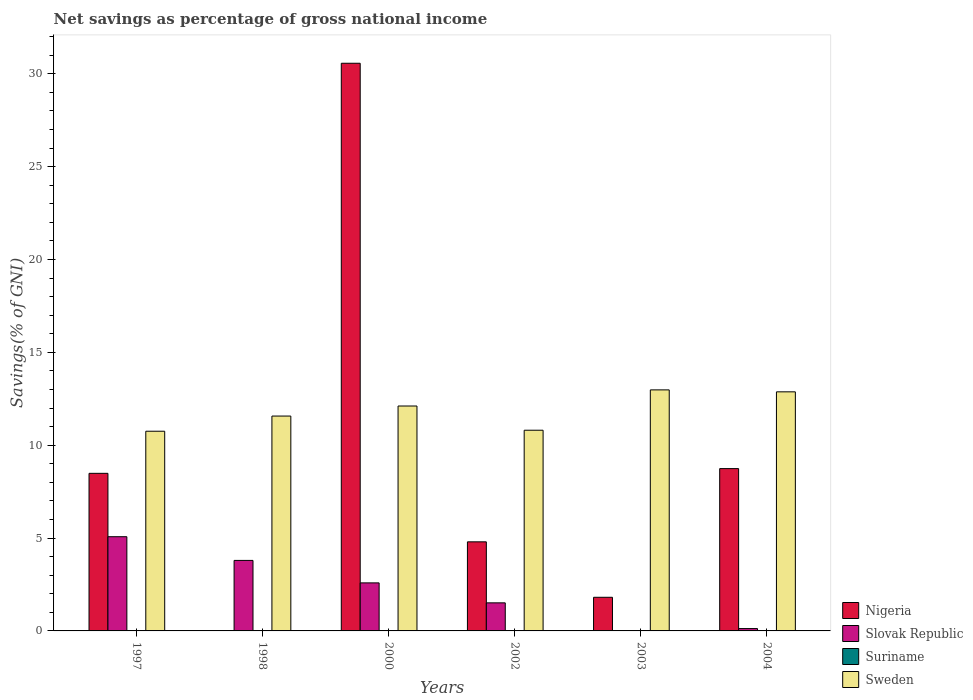How many bars are there on the 1st tick from the right?
Your response must be concise. 3. What is the label of the 4th group of bars from the left?
Give a very brief answer. 2002. What is the total savings in Suriname in 1997?
Your answer should be very brief. 0. Across all years, what is the maximum total savings in Slovak Republic?
Offer a terse response. 5.07. What is the total total savings in Slovak Republic in the graph?
Your answer should be compact. 13.09. What is the difference between the total savings in Sweden in 1998 and that in 2004?
Offer a very short reply. -1.3. What is the difference between the total savings in Nigeria in 2000 and the total savings in Slovak Republic in 1997?
Your response must be concise. 25.49. What is the average total savings in Nigeria per year?
Ensure brevity in your answer.  9.07. In the year 2000, what is the difference between the total savings in Sweden and total savings in Slovak Republic?
Offer a terse response. 9.52. In how many years, is the total savings in Suriname greater than 26 %?
Give a very brief answer. 0. What is the ratio of the total savings in Nigeria in 2000 to that in 2003?
Your answer should be compact. 16.88. Is the total savings in Sweden in 2002 less than that in 2003?
Provide a short and direct response. Yes. Is the difference between the total savings in Sweden in 1998 and 2002 greater than the difference between the total savings in Slovak Republic in 1998 and 2002?
Give a very brief answer. No. What is the difference between the highest and the second highest total savings in Nigeria?
Ensure brevity in your answer.  21.83. What is the difference between the highest and the lowest total savings in Slovak Republic?
Offer a terse response. 5.07. In how many years, is the total savings in Suriname greater than the average total savings in Suriname taken over all years?
Make the answer very short. 0. Is the sum of the total savings in Sweden in 1998 and 2002 greater than the maximum total savings in Suriname across all years?
Offer a terse response. Yes. Are all the bars in the graph horizontal?
Give a very brief answer. No. What is the difference between two consecutive major ticks on the Y-axis?
Make the answer very short. 5. Are the values on the major ticks of Y-axis written in scientific E-notation?
Give a very brief answer. No. Where does the legend appear in the graph?
Keep it short and to the point. Bottom right. How many legend labels are there?
Provide a succinct answer. 4. How are the legend labels stacked?
Offer a terse response. Vertical. What is the title of the graph?
Offer a terse response. Net savings as percentage of gross national income. Does "Hong Kong" appear as one of the legend labels in the graph?
Offer a terse response. No. What is the label or title of the X-axis?
Your answer should be very brief. Years. What is the label or title of the Y-axis?
Offer a very short reply. Savings(% of GNI). What is the Savings(% of GNI) of Nigeria in 1997?
Your answer should be very brief. 8.49. What is the Savings(% of GNI) of Slovak Republic in 1997?
Offer a terse response. 5.07. What is the Savings(% of GNI) in Sweden in 1997?
Keep it short and to the point. 10.75. What is the Savings(% of GNI) of Nigeria in 1998?
Offer a very short reply. 0. What is the Savings(% of GNI) in Slovak Republic in 1998?
Provide a succinct answer. 3.8. What is the Savings(% of GNI) in Sweden in 1998?
Your answer should be very brief. 11.57. What is the Savings(% of GNI) in Nigeria in 2000?
Your answer should be compact. 30.57. What is the Savings(% of GNI) in Slovak Republic in 2000?
Give a very brief answer. 2.59. What is the Savings(% of GNI) of Sweden in 2000?
Keep it short and to the point. 12.11. What is the Savings(% of GNI) in Nigeria in 2002?
Your answer should be very brief. 4.8. What is the Savings(% of GNI) in Slovak Republic in 2002?
Offer a very short reply. 1.51. What is the Savings(% of GNI) in Suriname in 2002?
Ensure brevity in your answer.  0. What is the Savings(% of GNI) of Sweden in 2002?
Give a very brief answer. 10.81. What is the Savings(% of GNI) of Nigeria in 2003?
Your answer should be compact. 1.81. What is the Savings(% of GNI) in Slovak Republic in 2003?
Keep it short and to the point. 0. What is the Savings(% of GNI) in Sweden in 2003?
Provide a short and direct response. 12.98. What is the Savings(% of GNI) of Nigeria in 2004?
Your response must be concise. 8.74. What is the Savings(% of GNI) in Slovak Republic in 2004?
Your answer should be very brief. 0.13. What is the Savings(% of GNI) in Suriname in 2004?
Ensure brevity in your answer.  0. What is the Savings(% of GNI) of Sweden in 2004?
Your response must be concise. 12.87. Across all years, what is the maximum Savings(% of GNI) in Nigeria?
Offer a terse response. 30.57. Across all years, what is the maximum Savings(% of GNI) of Slovak Republic?
Offer a terse response. 5.07. Across all years, what is the maximum Savings(% of GNI) of Sweden?
Keep it short and to the point. 12.98. Across all years, what is the minimum Savings(% of GNI) of Slovak Republic?
Offer a terse response. 0. Across all years, what is the minimum Savings(% of GNI) of Sweden?
Offer a terse response. 10.75. What is the total Savings(% of GNI) of Nigeria in the graph?
Offer a very short reply. 54.4. What is the total Savings(% of GNI) of Slovak Republic in the graph?
Offer a very short reply. 13.09. What is the total Savings(% of GNI) of Suriname in the graph?
Offer a terse response. 0. What is the total Savings(% of GNI) in Sweden in the graph?
Provide a succinct answer. 71.1. What is the difference between the Savings(% of GNI) of Slovak Republic in 1997 and that in 1998?
Give a very brief answer. 1.28. What is the difference between the Savings(% of GNI) in Sweden in 1997 and that in 1998?
Your answer should be very brief. -0.82. What is the difference between the Savings(% of GNI) of Nigeria in 1997 and that in 2000?
Keep it short and to the point. -22.08. What is the difference between the Savings(% of GNI) in Slovak Republic in 1997 and that in 2000?
Ensure brevity in your answer.  2.49. What is the difference between the Savings(% of GNI) of Sweden in 1997 and that in 2000?
Provide a succinct answer. -1.36. What is the difference between the Savings(% of GNI) of Nigeria in 1997 and that in 2002?
Give a very brief answer. 3.69. What is the difference between the Savings(% of GNI) in Slovak Republic in 1997 and that in 2002?
Offer a terse response. 3.56. What is the difference between the Savings(% of GNI) in Sweden in 1997 and that in 2002?
Keep it short and to the point. -0.05. What is the difference between the Savings(% of GNI) of Nigeria in 1997 and that in 2003?
Offer a very short reply. 6.67. What is the difference between the Savings(% of GNI) of Sweden in 1997 and that in 2003?
Keep it short and to the point. -2.23. What is the difference between the Savings(% of GNI) of Nigeria in 1997 and that in 2004?
Offer a terse response. -0.26. What is the difference between the Savings(% of GNI) in Slovak Republic in 1997 and that in 2004?
Provide a succinct answer. 4.95. What is the difference between the Savings(% of GNI) of Sweden in 1997 and that in 2004?
Your response must be concise. -2.12. What is the difference between the Savings(% of GNI) in Slovak Republic in 1998 and that in 2000?
Your answer should be very brief. 1.21. What is the difference between the Savings(% of GNI) in Sweden in 1998 and that in 2000?
Your answer should be compact. -0.54. What is the difference between the Savings(% of GNI) of Slovak Republic in 1998 and that in 2002?
Your answer should be very brief. 2.28. What is the difference between the Savings(% of GNI) of Sweden in 1998 and that in 2002?
Offer a terse response. 0.76. What is the difference between the Savings(% of GNI) in Sweden in 1998 and that in 2003?
Provide a succinct answer. -1.41. What is the difference between the Savings(% of GNI) of Slovak Republic in 1998 and that in 2004?
Your answer should be very brief. 3.67. What is the difference between the Savings(% of GNI) of Sweden in 1998 and that in 2004?
Give a very brief answer. -1.3. What is the difference between the Savings(% of GNI) of Nigeria in 2000 and that in 2002?
Your response must be concise. 25.77. What is the difference between the Savings(% of GNI) of Slovak Republic in 2000 and that in 2002?
Your response must be concise. 1.07. What is the difference between the Savings(% of GNI) of Sweden in 2000 and that in 2002?
Keep it short and to the point. 1.3. What is the difference between the Savings(% of GNI) in Nigeria in 2000 and that in 2003?
Provide a short and direct response. 28.76. What is the difference between the Savings(% of GNI) of Sweden in 2000 and that in 2003?
Ensure brevity in your answer.  -0.87. What is the difference between the Savings(% of GNI) in Nigeria in 2000 and that in 2004?
Your response must be concise. 21.83. What is the difference between the Savings(% of GNI) in Slovak Republic in 2000 and that in 2004?
Give a very brief answer. 2.46. What is the difference between the Savings(% of GNI) in Sweden in 2000 and that in 2004?
Provide a short and direct response. -0.76. What is the difference between the Savings(% of GNI) of Nigeria in 2002 and that in 2003?
Ensure brevity in your answer.  2.99. What is the difference between the Savings(% of GNI) of Sweden in 2002 and that in 2003?
Make the answer very short. -2.17. What is the difference between the Savings(% of GNI) of Nigeria in 2002 and that in 2004?
Provide a short and direct response. -3.94. What is the difference between the Savings(% of GNI) of Slovak Republic in 2002 and that in 2004?
Provide a short and direct response. 1.39. What is the difference between the Savings(% of GNI) in Sweden in 2002 and that in 2004?
Offer a terse response. -2.07. What is the difference between the Savings(% of GNI) in Nigeria in 2003 and that in 2004?
Provide a succinct answer. -6.93. What is the difference between the Savings(% of GNI) in Sweden in 2003 and that in 2004?
Offer a terse response. 0.1. What is the difference between the Savings(% of GNI) in Nigeria in 1997 and the Savings(% of GNI) in Slovak Republic in 1998?
Your answer should be very brief. 4.69. What is the difference between the Savings(% of GNI) in Nigeria in 1997 and the Savings(% of GNI) in Sweden in 1998?
Provide a short and direct response. -3.08. What is the difference between the Savings(% of GNI) of Slovak Republic in 1997 and the Savings(% of GNI) of Sweden in 1998?
Offer a terse response. -6.5. What is the difference between the Savings(% of GNI) of Nigeria in 1997 and the Savings(% of GNI) of Slovak Republic in 2000?
Your response must be concise. 5.9. What is the difference between the Savings(% of GNI) in Nigeria in 1997 and the Savings(% of GNI) in Sweden in 2000?
Make the answer very short. -3.63. What is the difference between the Savings(% of GNI) of Slovak Republic in 1997 and the Savings(% of GNI) of Sweden in 2000?
Provide a short and direct response. -7.04. What is the difference between the Savings(% of GNI) of Nigeria in 1997 and the Savings(% of GNI) of Slovak Republic in 2002?
Ensure brevity in your answer.  6.97. What is the difference between the Savings(% of GNI) of Nigeria in 1997 and the Savings(% of GNI) of Sweden in 2002?
Provide a succinct answer. -2.32. What is the difference between the Savings(% of GNI) of Slovak Republic in 1997 and the Savings(% of GNI) of Sweden in 2002?
Provide a succinct answer. -5.73. What is the difference between the Savings(% of GNI) in Nigeria in 1997 and the Savings(% of GNI) in Sweden in 2003?
Your response must be concise. -4.49. What is the difference between the Savings(% of GNI) in Slovak Republic in 1997 and the Savings(% of GNI) in Sweden in 2003?
Your answer should be compact. -7.91. What is the difference between the Savings(% of GNI) of Nigeria in 1997 and the Savings(% of GNI) of Slovak Republic in 2004?
Offer a very short reply. 8.36. What is the difference between the Savings(% of GNI) in Nigeria in 1997 and the Savings(% of GNI) in Sweden in 2004?
Keep it short and to the point. -4.39. What is the difference between the Savings(% of GNI) in Slovak Republic in 1997 and the Savings(% of GNI) in Sweden in 2004?
Provide a short and direct response. -7.8. What is the difference between the Savings(% of GNI) in Slovak Republic in 1998 and the Savings(% of GNI) in Sweden in 2000?
Your response must be concise. -8.31. What is the difference between the Savings(% of GNI) in Slovak Republic in 1998 and the Savings(% of GNI) in Sweden in 2002?
Your answer should be very brief. -7.01. What is the difference between the Savings(% of GNI) of Slovak Republic in 1998 and the Savings(% of GNI) of Sweden in 2003?
Your response must be concise. -9.18. What is the difference between the Savings(% of GNI) in Slovak Republic in 1998 and the Savings(% of GNI) in Sweden in 2004?
Offer a very short reply. -9.08. What is the difference between the Savings(% of GNI) in Nigeria in 2000 and the Savings(% of GNI) in Slovak Republic in 2002?
Your response must be concise. 29.06. What is the difference between the Savings(% of GNI) of Nigeria in 2000 and the Savings(% of GNI) of Sweden in 2002?
Offer a terse response. 19.76. What is the difference between the Savings(% of GNI) in Slovak Republic in 2000 and the Savings(% of GNI) in Sweden in 2002?
Provide a succinct answer. -8.22. What is the difference between the Savings(% of GNI) in Nigeria in 2000 and the Savings(% of GNI) in Sweden in 2003?
Ensure brevity in your answer.  17.59. What is the difference between the Savings(% of GNI) of Slovak Republic in 2000 and the Savings(% of GNI) of Sweden in 2003?
Give a very brief answer. -10.39. What is the difference between the Savings(% of GNI) in Nigeria in 2000 and the Savings(% of GNI) in Slovak Republic in 2004?
Keep it short and to the point. 30.44. What is the difference between the Savings(% of GNI) in Nigeria in 2000 and the Savings(% of GNI) in Sweden in 2004?
Make the answer very short. 17.69. What is the difference between the Savings(% of GNI) in Slovak Republic in 2000 and the Savings(% of GNI) in Sweden in 2004?
Give a very brief answer. -10.29. What is the difference between the Savings(% of GNI) of Nigeria in 2002 and the Savings(% of GNI) of Sweden in 2003?
Your answer should be compact. -8.18. What is the difference between the Savings(% of GNI) of Slovak Republic in 2002 and the Savings(% of GNI) of Sweden in 2003?
Make the answer very short. -11.47. What is the difference between the Savings(% of GNI) of Nigeria in 2002 and the Savings(% of GNI) of Slovak Republic in 2004?
Provide a short and direct response. 4.67. What is the difference between the Savings(% of GNI) of Nigeria in 2002 and the Savings(% of GNI) of Sweden in 2004?
Your answer should be compact. -8.08. What is the difference between the Savings(% of GNI) of Slovak Republic in 2002 and the Savings(% of GNI) of Sweden in 2004?
Provide a succinct answer. -11.36. What is the difference between the Savings(% of GNI) in Nigeria in 2003 and the Savings(% of GNI) in Slovak Republic in 2004?
Your answer should be very brief. 1.68. What is the difference between the Savings(% of GNI) of Nigeria in 2003 and the Savings(% of GNI) of Sweden in 2004?
Ensure brevity in your answer.  -11.06. What is the average Savings(% of GNI) of Nigeria per year?
Provide a succinct answer. 9.07. What is the average Savings(% of GNI) in Slovak Republic per year?
Keep it short and to the point. 2.18. What is the average Savings(% of GNI) of Sweden per year?
Offer a very short reply. 11.85. In the year 1997, what is the difference between the Savings(% of GNI) of Nigeria and Savings(% of GNI) of Slovak Republic?
Give a very brief answer. 3.41. In the year 1997, what is the difference between the Savings(% of GNI) of Nigeria and Savings(% of GNI) of Sweden?
Offer a very short reply. -2.27. In the year 1997, what is the difference between the Savings(% of GNI) in Slovak Republic and Savings(% of GNI) in Sweden?
Give a very brief answer. -5.68. In the year 1998, what is the difference between the Savings(% of GNI) in Slovak Republic and Savings(% of GNI) in Sweden?
Keep it short and to the point. -7.77. In the year 2000, what is the difference between the Savings(% of GNI) of Nigeria and Savings(% of GNI) of Slovak Republic?
Provide a succinct answer. 27.98. In the year 2000, what is the difference between the Savings(% of GNI) of Nigeria and Savings(% of GNI) of Sweden?
Your response must be concise. 18.46. In the year 2000, what is the difference between the Savings(% of GNI) of Slovak Republic and Savings(% of GNI) of Sweden?
Ensure brevity in your answer.  -9.52. In the year 2002, what is the difference between the Savings(% of GNI) of Nigeria and Savings(% of GNI) of Slovak Republic?
Keep it short and to the point. 3.29. In the year 2002, what is the difference between the Savings(% of GNI) of Nigeria and Savings(% of GNI) of Sweden?
Ensure brevity in your answer.  -6.01. In the year 2002, what is the difference between the Savings(% of GNI) in Slovak Republic and Savings(% of GNI) in Sweden?
Make the answer very short. -9.3. In the year 2003, what is the difference between the Savings(% of GNI) in Nigeria and Savings(% of GNI) in Sweden?
Ensure brevity in your answer.  -11.17. In the year 2004, what is the difference between the Savings(% of GNI) of Nigeria and Savings(% of GNI) of Slovak Republic?
Your answer should be very brief. 8.61. In the year 2004, what is the difference between the Savings(% of GNI) of Nigeria and Savings(% of GNI) of Sweden?
Provide a succinct answer. -4.13. In the year 2004, what is the difference between the Savings(% of GNI) of Slovak Republic and Savings(% of GNI) of Sweden?
Your response must be concise. -12.75. What is the ratio of the Savings(% of GNI) in Slovak Republic in 1997 to that in 1998?
Offer a terse response. 1.34. What is the ratio of the Savings(% of GNI) of Sweden in 1997 to that in 1998?
Provide a succinct answer. 0.93. What is the ratio of the Savings(% of GNI) of Nigeria in 1997 to that in 2000?
Your answer should be very brief. 0.28. What is the ratio of the Savings(% of GNI) in Slovak Republic in 1997 to that in 2000?
Provide a short and direct response. 1.96. What is the ratio of the Savings(% of GNI) of Sweden in 1997 to that in 2000?
Give a very brief answer. 0.89. What is the ratio of the Savings(% of GNI) of Nigeria in 1997 to that in 2002?
Keep it short and to the point. 1.77. What is the ratio of the Savings(% of GNI) of Slovak Republic in 1997 to that in 2002?
Your answer should be compact. 3.36. What is the ratio of the Savings(% of GNI) of Sweden in 1997 to that in 2002?
Your answer should be compact. 0.99. What is the ratio of the Savings(% of GNI) of Nigeria in 1997 to that in 2003?
Ensure brevity in your answer.  4.69. What is the ratio of the Savings(% of GNI) in Sweden in 1997 to that in 2003?
Give a very brief answer. 0.83. What is the ratio of the Savings(% of GNI) of Nigeria in 1997 to that in 2004?
Make the answer very short. 0.97. What is the ratio of the Savings(% of GNI) in Slovak Republic in 1997 to that in 2004?
Offer a terse response. 40.11. What is the ratio of the Savings(% of GNI) in Sweden in 1997 to that in 2004?
Provide a succinct answer. 0.84. What is the ratio of the Savings(% of GNI) of Slovak Republic in 1998 to that in 2000?
Make the answer very short. 1.47. What is the ratio of the Savings(% of GNI) in Sweden in 1998 to that in 2000?
Provide a succinct answer. 0.96. What is the ratio of the Savings(% of GNI) of Slovak Republic in 1998 to that in 2002?
Keep it short and to the point. 2.51. What is the ratio of the Savings(% of GNI) in Sweden in 1998 to that in 2002?
Make the answer very short. 1.07. What is the ratio of the Savings(% of GNI) in Sweden in 1998 to that in 2003?
Your answer should be compact. 0.89. What is the ratio of the Savings(% of GNI) in Slovak Republic in 1998 to that in 2004?
Offer a very short reply. 30.01. What is the ratio of the Savings(% of GNI) of Sweden in 1998 to that in 2004?
Your answer should be compact. 0.9. What is the ratio of the Savings(% of GNI) of Nigeria in 2000 to that in 2002?
Provide a succinct answer. 6.37. What is the ratio of the Savings(% of GNI) in Slovak Republic in 2000 to that in 2002?
Your answer should be very brief. 1.71. What is the ratio of the Savings(% of GNI) in Sweden in 2000 to that in 2002?
Make the answer very short. 1.12. What is the ratio of the Savings(% of GNI) in Nigeria in 2000 to that in 2003?
Ensure brevity in your answer.  16.88. What is the ratio of the Savings(% of GNI) of Sweden in 2000 to that in 2003?
Provide a succinct answer. 0.93. What is the ratio of the Savings(% of GNI) of Nigeria in 2000 to that in 2004?
Give a very brief answer. 3.5. What is the ratio of the Savings(% of GNI) in Slovak Republic in 2000 to that in 2004?
Ensure brevity in your answer.  20.45. What is the ratio of the Savings(% of GNI) of Sweden in 2000 to that in 2004?
Provide a succinct answer. 0.94. What is the ratio of the Savings(% of GNI) of Nigeria in 2002 to that in 2003?
Your answer should be compact. 2.65. What is the ratio of the Savings(% of GNI) of Sweden in 2002 to that in 2003?
Your response must be concise. 0.83. What is the ratio of the Savings(% of GNI) in Nigeria in 2002 to that in 2004?
Offer a very short reply. 0.55. What is the ratio of the Savings(% of GNI) in Slovak Republic in 2002 to that in 2004?
Offer a terse response. 11.95. What is the ratio of the Savings(% of GNI) in Sweden in 2002 to that in 2004?
Your answer should be compact. 0.84. What is the ratio of the Savings(% of GNI) of Nigeria in 2003 to that in 2004?
Ensure brevity in your answer.  0.21. What is the ratio of the Savings(% of GNI) in Sweden in 2003 to that in 2004?
Provide a short and direct response. 1.01. What is the difference between the highest and the second highest Savings(% of GNI) of Nigeria?
Offer a terse response. 21.83. What is the difference between the highest and the second highest Savings(% of GNI) in Slovak Republic?
Keep it short and to the point. 1.28. What is the difference between the highest and the second highest Savings(% of GNI) of Sweden?
Your answer should be compact. 0.1. What is the difference between the highest and the lowest Savings(% of GNI) of Nigeria?
Your answer should be compact. 30.57. What is the difference between the highest and the lowest Savings(% of GNI) in Slovak Republic?
Your answer should be very brief. 5.07. What is the difference between the highest and the lowest Savings(% of GNI) of Sweden?
Make the answer very short. 2.23. 